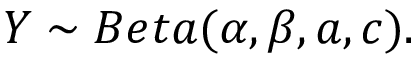Convert formula to latex. <formula><loc_0><loc_0><loc_500><loc_500>Y \sim B e t a ( \alpha , \beta , a , c ) .</formula> 